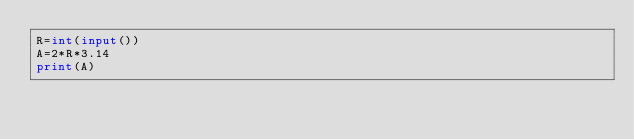Convert code to text. <code><loc_0><loc_0><loc_500><loc_500><_Python_>R=int(input())
A=2*R*3.14
print(A)</code> 